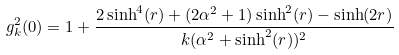<formula> <loc_0><loc_0><loc_500><loc_500>g ^ { 2 } _ { k } ( 0 ) = 1 + \frac { 2 \sinh ^ { 4 } ( r ) + ( 2 \alpha ^ { 2 } + 1 ) \sinh ^ { 2 } ( r ) - \sinh ( 2 r ) } { k ( \alpha ^ { 2 } + \sinh ^ { 2 } ( r ) ) ^ { 2 } }</formula> 